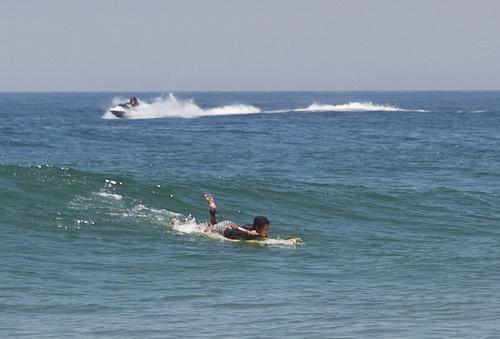How many people are shown in this scene?
Give a very brief answer. 2. 